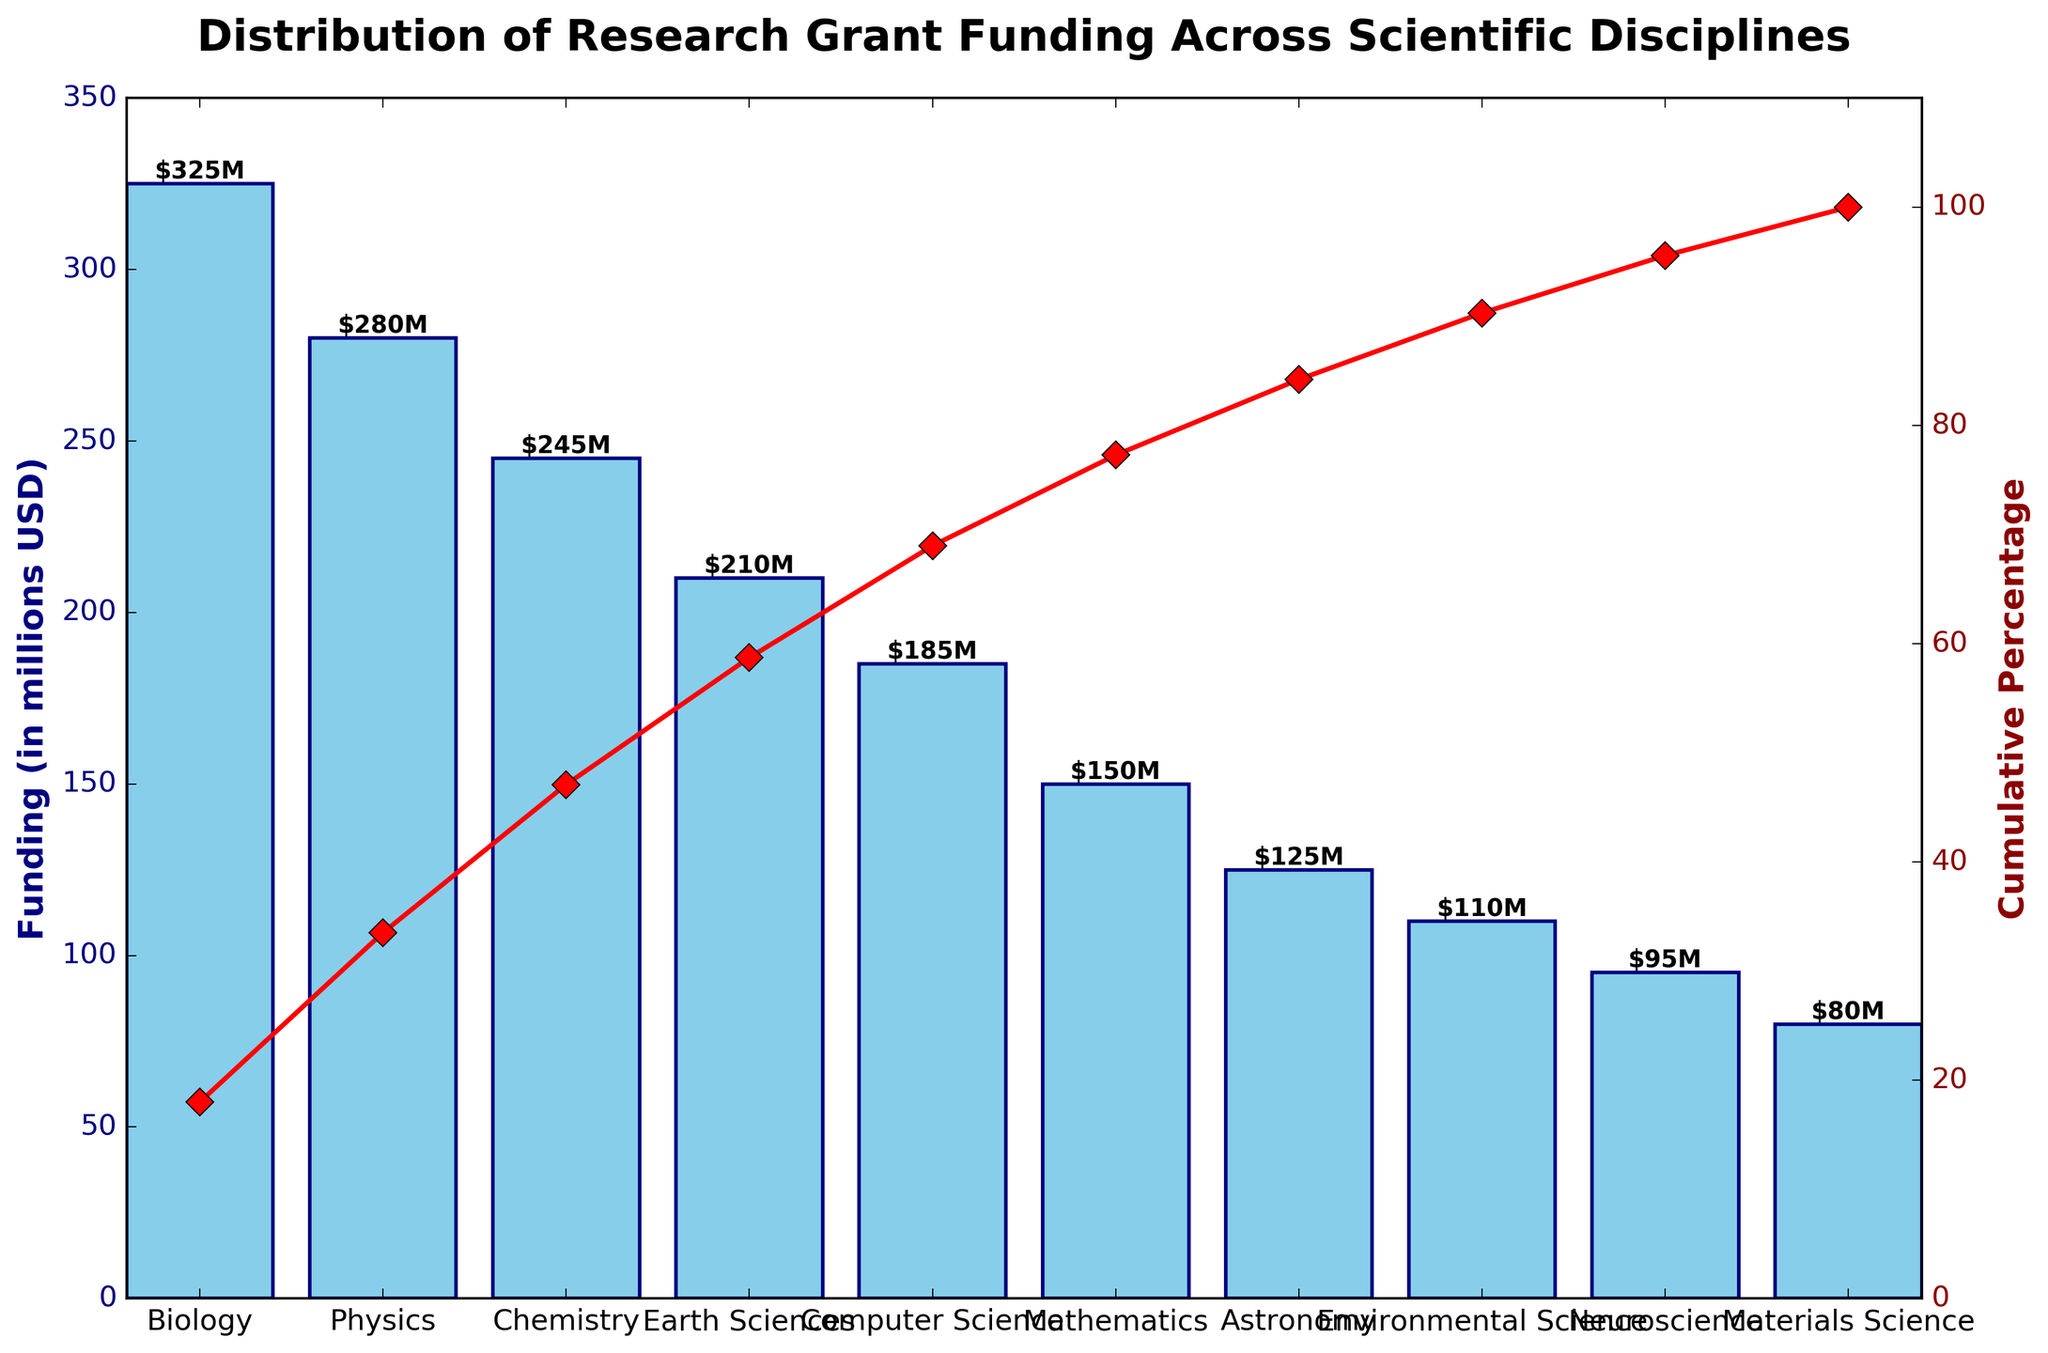What is the funding amount for Biology? Look for the bar representing "Biology" on the X-axis and check the height of the bar on the Y-axis. The label on the bar states the funding amount.
Answer: $325M What percentage of the cumulative funding is reached by the top three disciplines? Identify the top three funded disciplines: Biology, Physics, and Chemistry. Check the cumulative percentage line that crosses Chemistry's vertical, which gives the cumulative percentage at that point.
Answer: 64.8% Which discipline has the lowest funding? Look for the shortest bar in the chart. The label "Materials Science" corresponds to the shortest bar.
Answer: Materials Science How does the funding for Physics compare to Astronomy? Find the bars for Physics and Astronomy. Physics has a funding amount of $280M while Astronomy has $125M.
Answer: Physics funding is $155M higher than Astronomy What is the total funding amount for Earth Sciences and Environmental Science combined? Locate the bars for Earth Sciences ($210M) and Environmental Science ($110M) and add their values together.
Answer: $320M What is the funding difference between the highest and lowest funded disciplines? The highest funded discipline is Biology ($325M) and the lowest funded is Materials Science ($80M). Calculate $325M - $80M.
Answer: $245M At what cumulative percentage is reached by Computer Science? Look for the point where the Computer Science bar ends, and check its corresponding value on the cumulative percentage line.
Answer: 83.6% Which three disciplines together surpass 50% of the total funding? Identify the top disciplines: Biology, Physics, and Chemistry. Their cumulative percentage surpasses 50% at Chemistry's end.
Answer: Biology, Physics, Chemistry How many disciplines have their individual funding amounts below $200M? Count the bars whose heights correspond to funding amounts less than $200M: Computer Science, Mathematics, Astronomy, Environmental Science, Neuroscience, Materials Science.
Answer: 6 What is the cumulative funding percentage for Neuroscience? Locate the Neuroscience bar and follow it to the cumulative percentage line.
Answer: 95.7% 